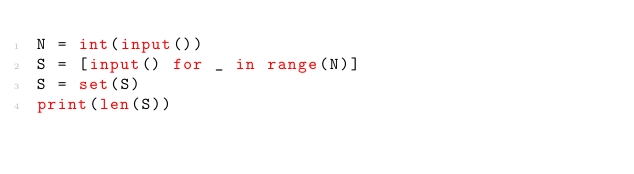<code> <loc_0><loc_0><loc_500><loc_500><_Python_>N = int(input()) 
S = [input() for _ in range(N)]
S = set(S)
print(len(S))</code> 